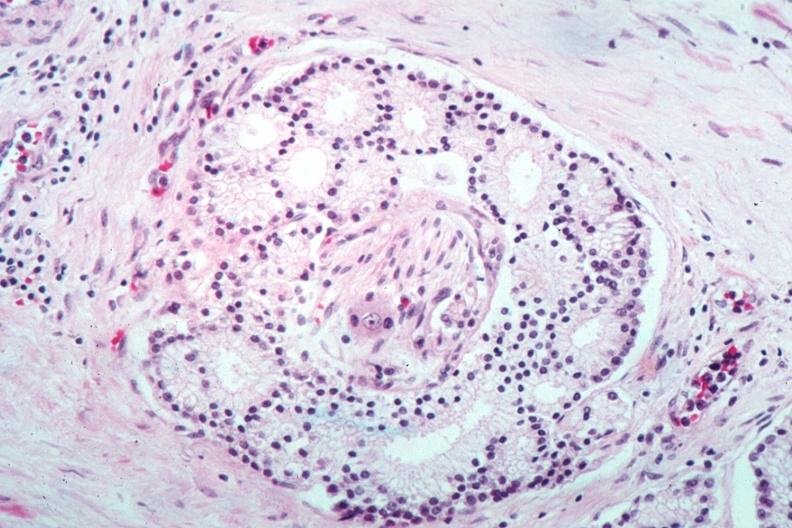what does this image show?
Answer the question using a single word or phrase. Nice photo of perineural invasion by well differentiated adenocarcinoma 